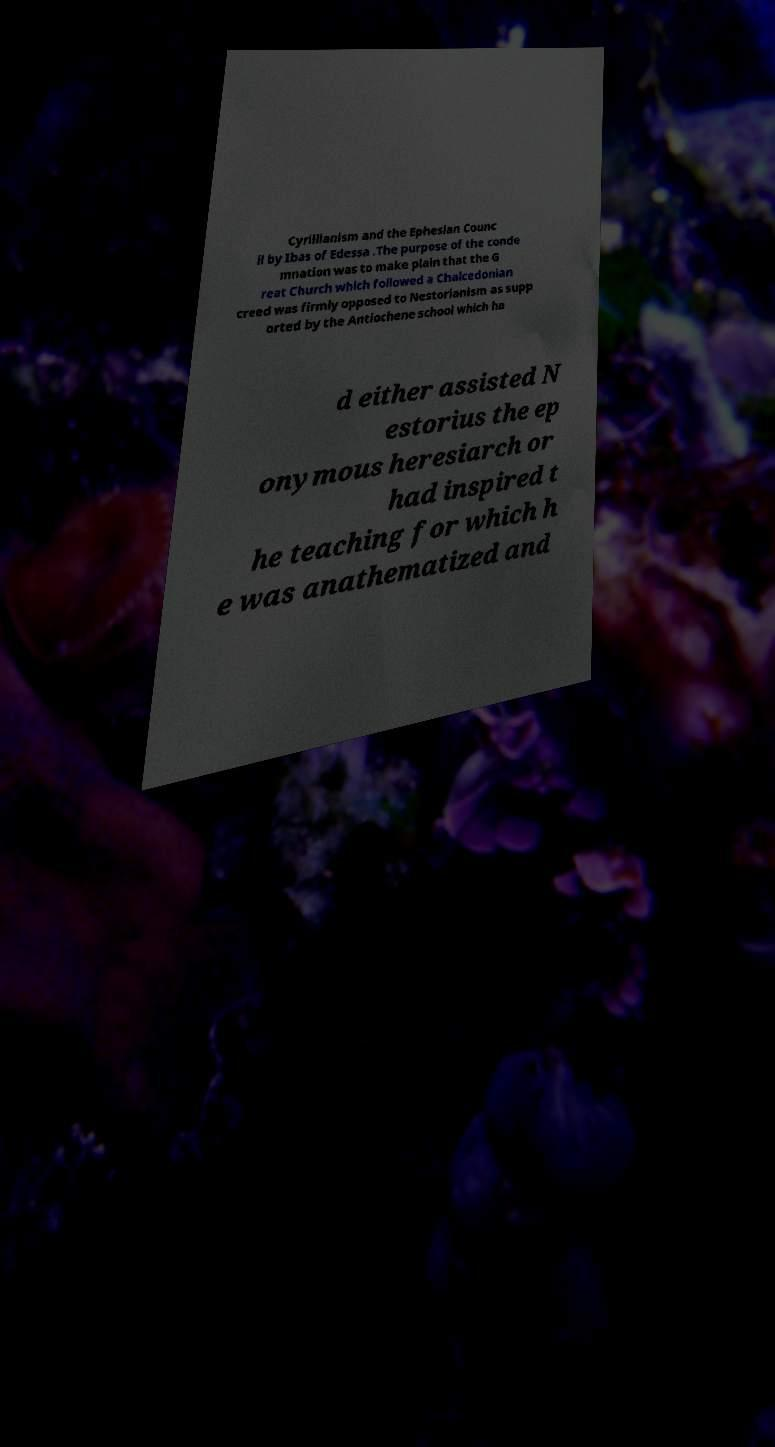Please read and relay the text visible in this image. What does it say? Cyrillianism and the Ephesian Counc il by Ibas of Edessa .The purpose of the conde mnation was to make plain that the G reat Church which followed a Chalcedonian creed was firmly opposed to Nestorianism as supp orted by the Antiochene school which ha d either assisted N estorius the ep onymous heresiarch or had inspired t he teaching for which h e was anathematized and 